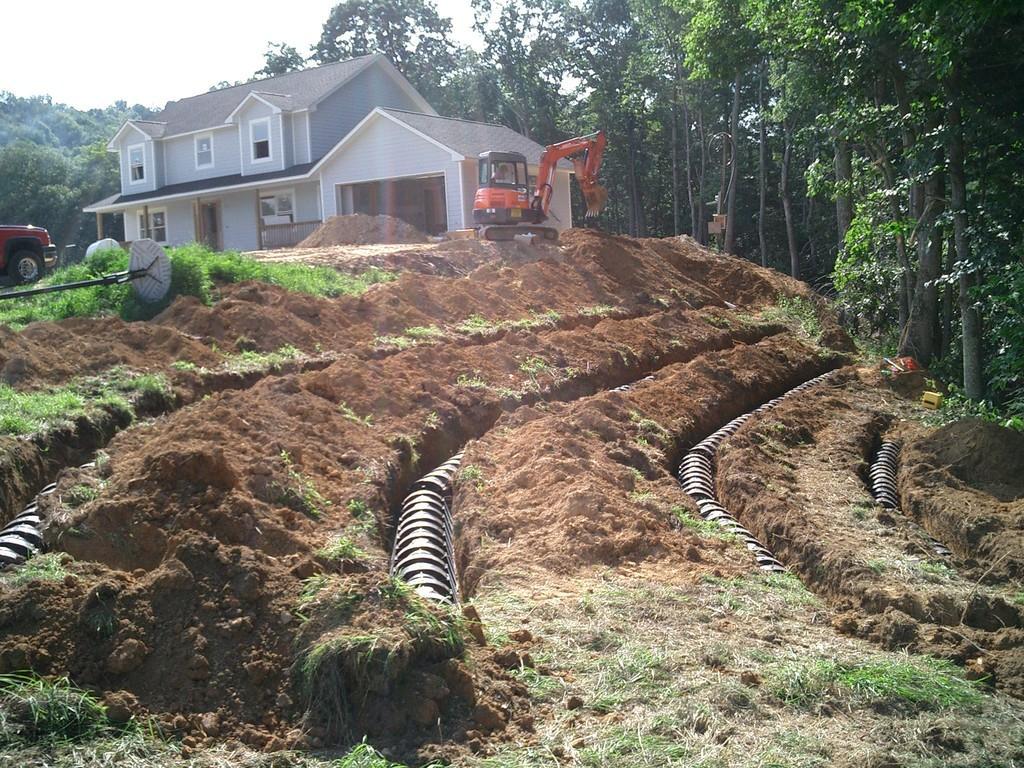In one or two sentences, can you explain what this image depicts? In the picture we can see a muddy surface and in the middle of it, we can see some pipes are laid and on the top of it, we can see the construction equipment, vehicle and beside it, we can see the house with windows and a door and near to it we can see a part of the car and in the background we can see many trees and the sky. 